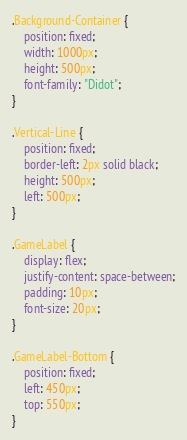Convert code to text. <code><loc_0><loc_0><loc_500><loc_500><_CSS_>.Background-Container {
    position: fixed;
    width: 1000px;
    height: 500px;
    font-family: "Didot";
}

.Vertical-Line {
    position: fixed;
    border-left: 2px solid black;
    height: 500px;
    left: 500px;
}

.GameLabel {
    display: flex;
    justify-content: space-between;
    padding: 10px;
    font-size: 20px;
}

.GameLabel-Bottom {
    position: fixed;
    left: 450px;
    top: 550px;
}</code> 